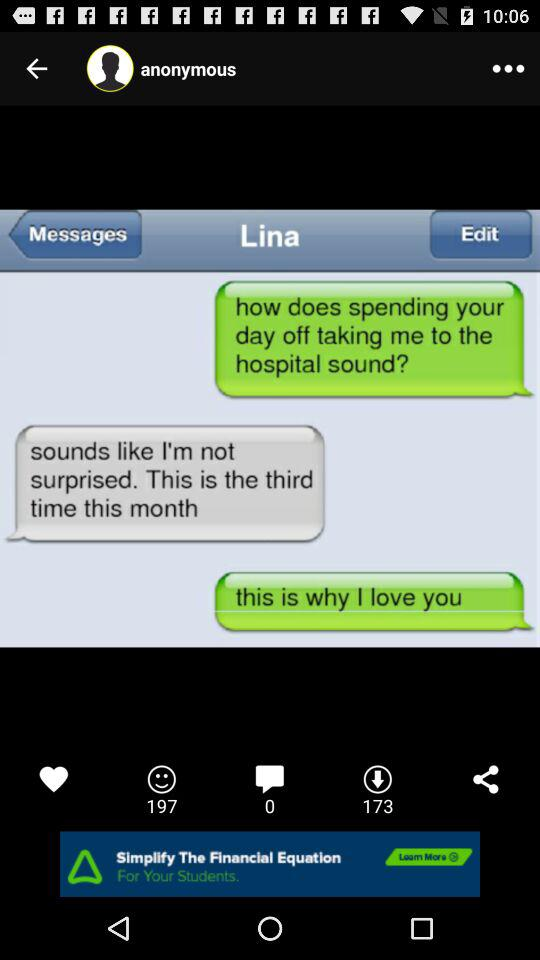What is the name of the user? The name of the user is Lina. 